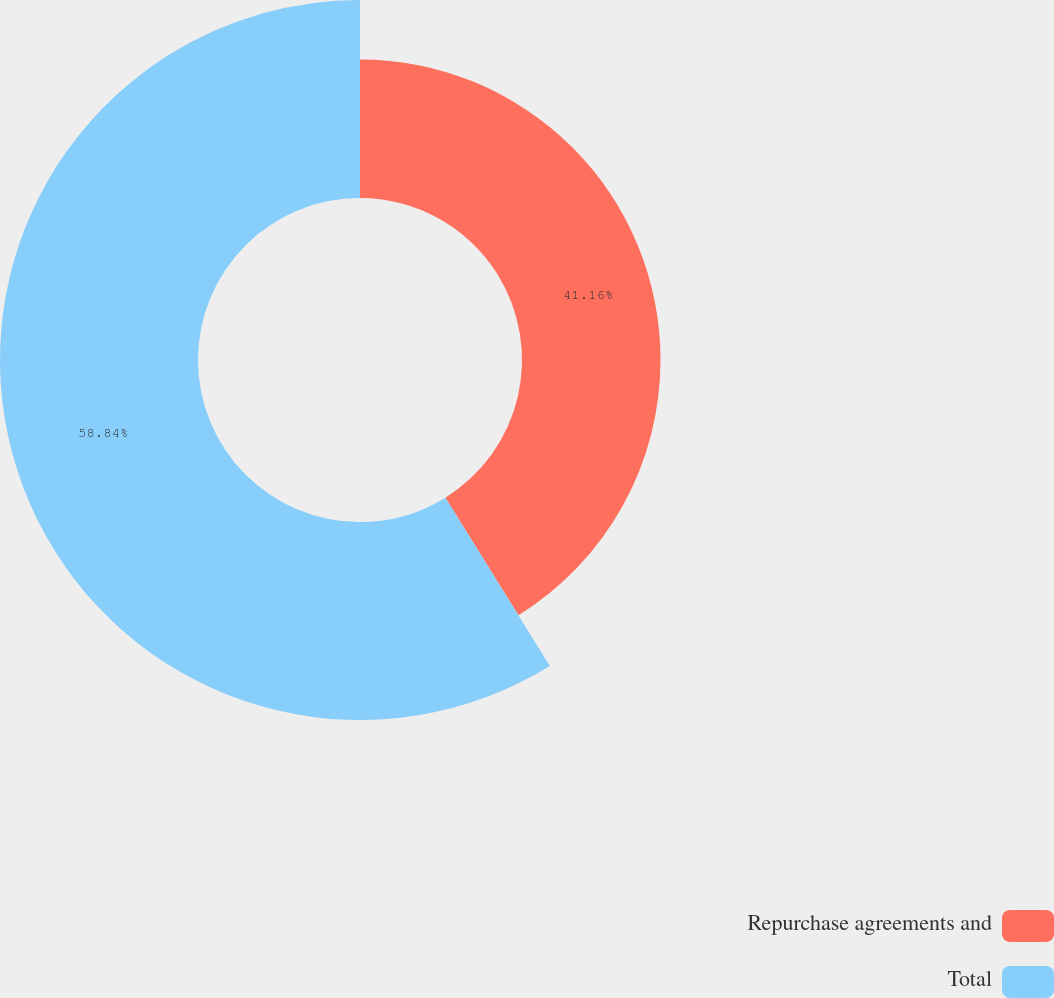<chart> <loc_0><loc_0><loc_500><loc_500><pie_chart><fcel>Repurchase agreements and<fcel>Total<nl><fcel>41.16%<fcel>58.84%<nl></chart> 